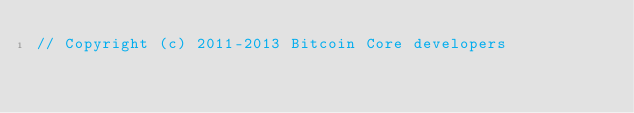<code> <loc_0><loc_0><loc_500><loc_500><_ObjectiveC_>// Copyright (c) 2011-2013 Bitcoin Core developers</code> 